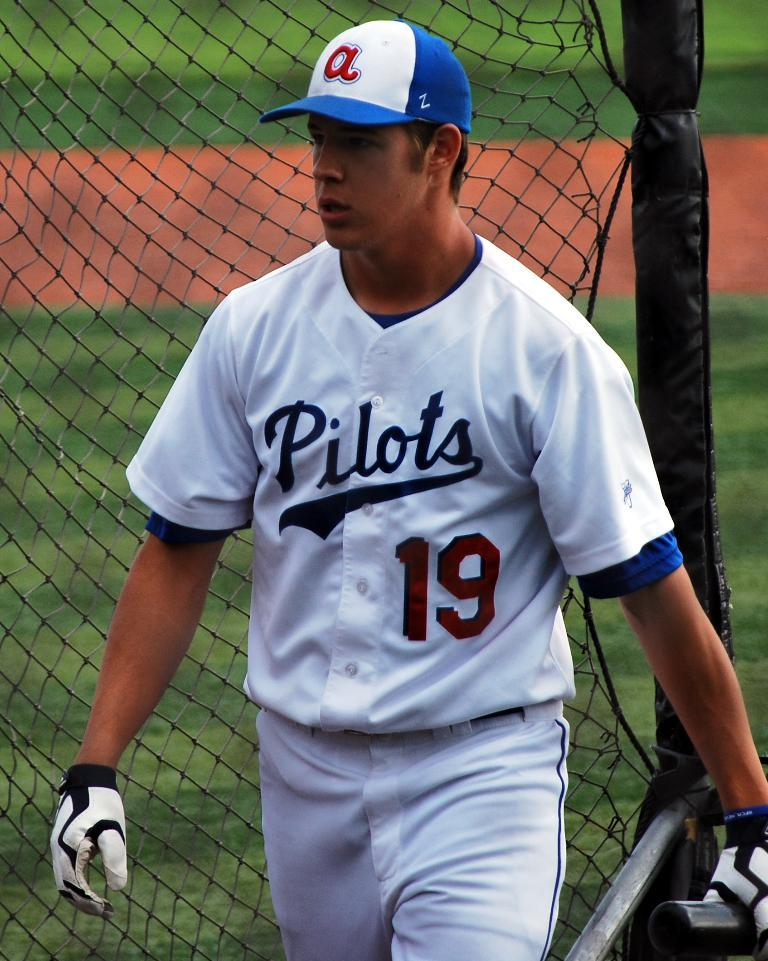<image>
Create a compact narrative representing the image presented. A player wears a Pilots jersey with number 19. 